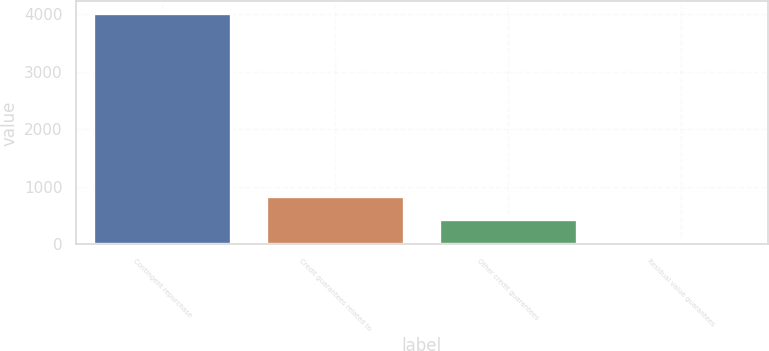<chart> <loc_0><loc_0><loc_500><loc_500><bar_chart><fcel>Contingent repurchase<fcel>Credit guarantees related to<fcel>Other credit guarantees<fcel>Residual value guarantees<nl><fcel>4024<fcel>845.6<fcel>448.3<fcel>51<nl></chart> 